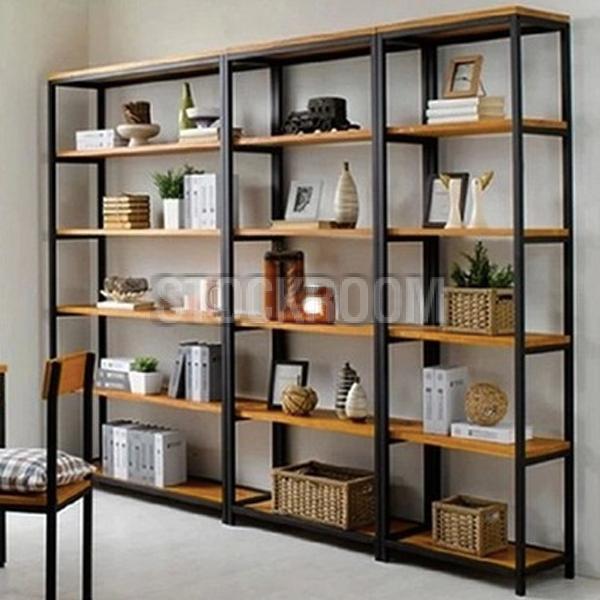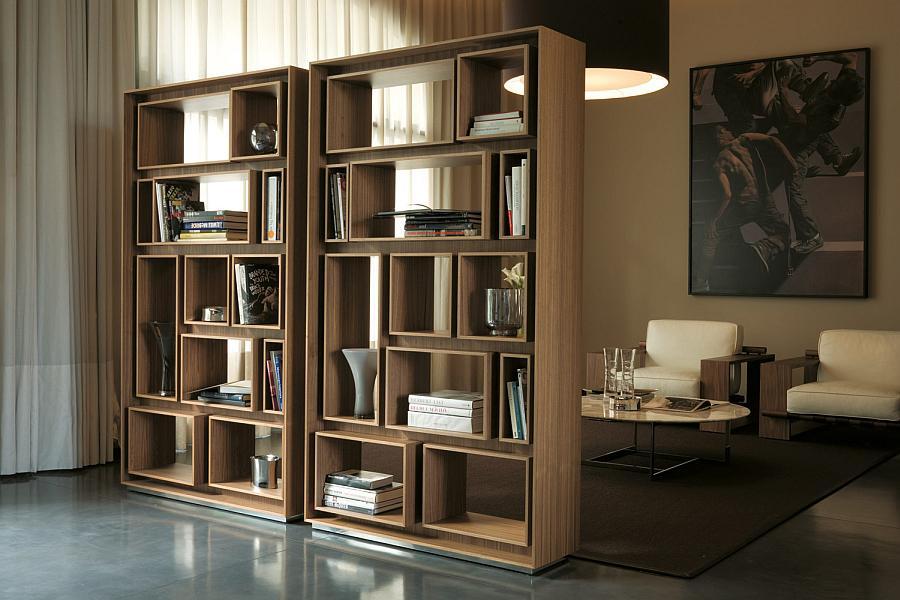The first image is the image on the left, the second image is the image on the right. Evaluate the accuracy of this statement regarding the images: "An image shows a tree-inspired wooden bookshelf with platform shelves.". Is it true? Answer yes or no. No. 